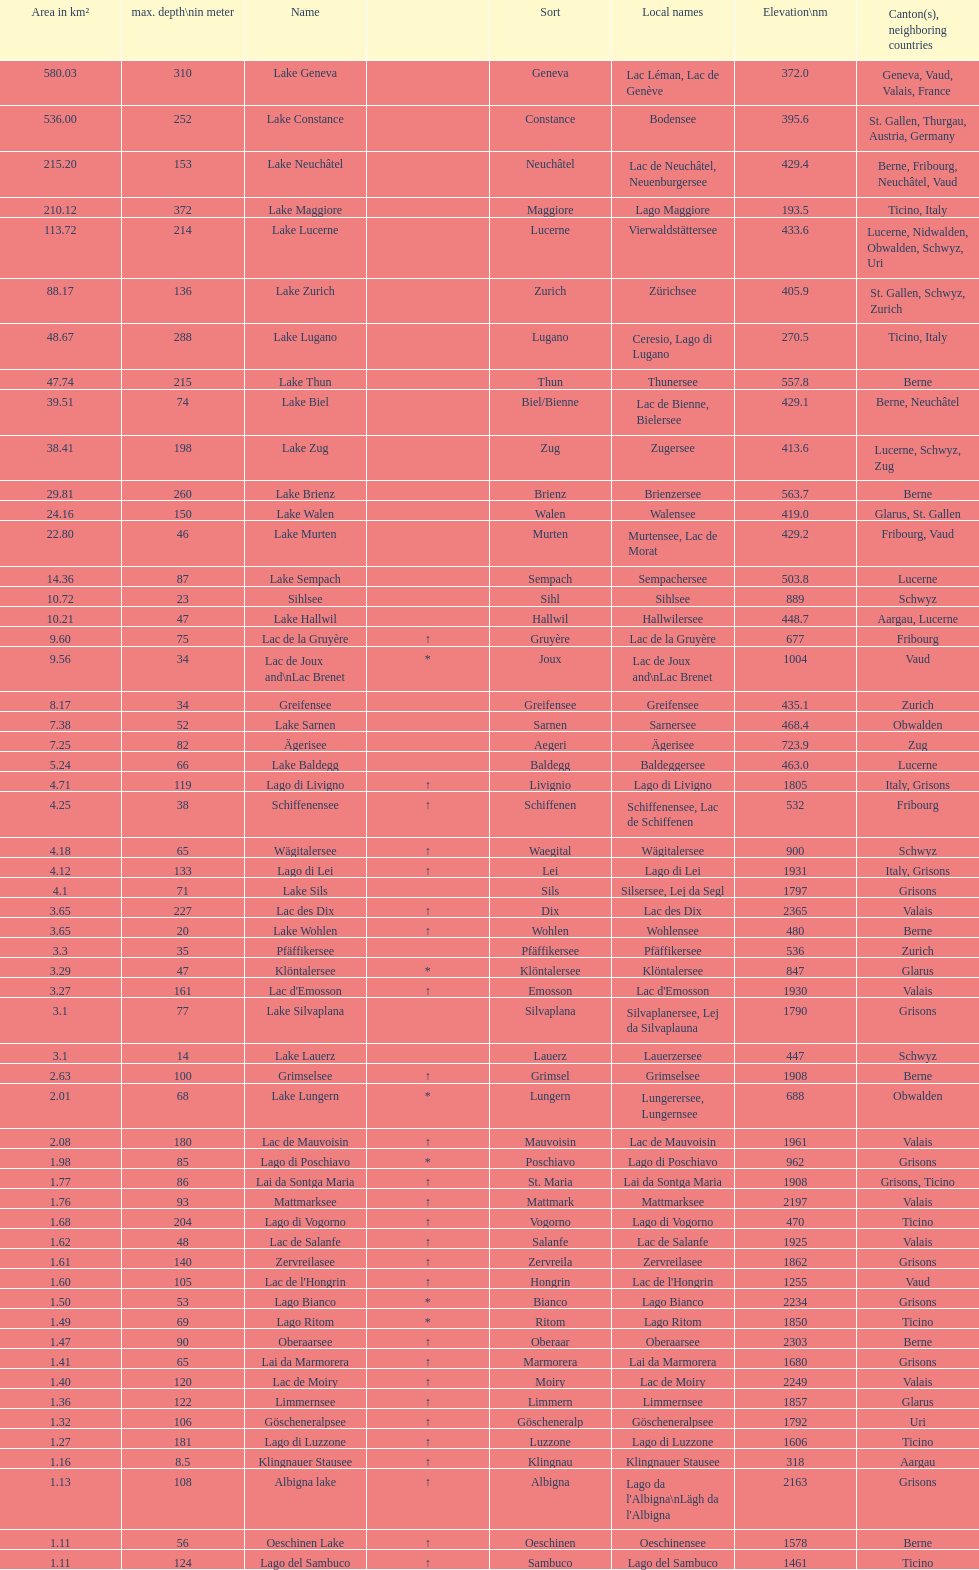What lake has the next highest elevation after lac des dix? Oberaarsee. 